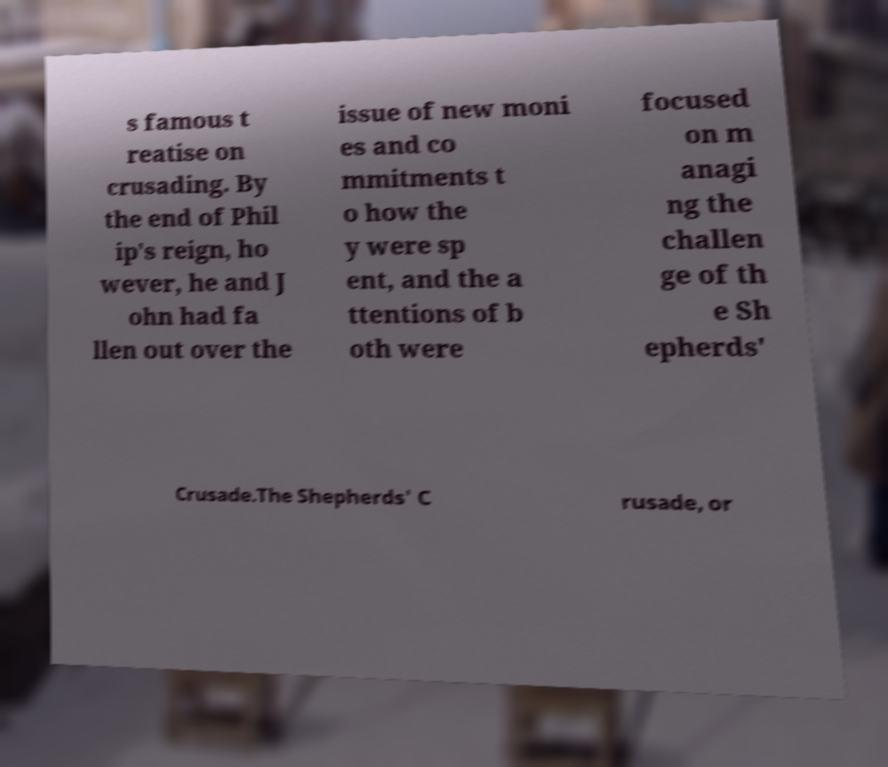For documentation purposes, I need the text within this image transcribed. Could you provide that? s famous t reatise on crusading. By the end of Phil ip's reign, ho wever, he and J ohn had fa llen out over the issue of new moni es and co mmitments t o how the y were sp ent, and the a ttentions of b oth were focused on m anagi ng the challen ge of th e Sh epherds' Crusade.The Shepherds' C rusade, or 